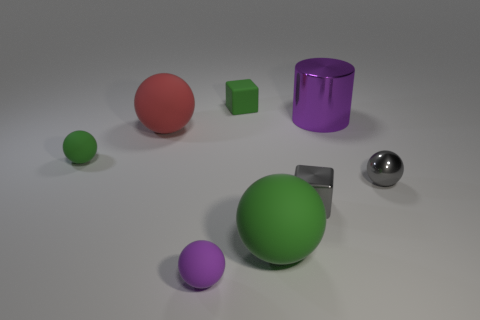What is the size of the green sphere that is right of the small cube behind the red matte object?
Make the answer very short. Large. What number of tiny objects are the same color as the cylinder?
Your answer should be very brief. 1. What shape is the purple thing behind the green thing that is on the left side of the green matte block?
Keep it short and to the point. Cylinder. How many green balls have the same material as the tiny green block?
Provide a succinct answer. 2. There is a small ball that is in front of the gray metal ball; what is its material?
Offer a terse response. Rubber. What shape is the large rubber thing that is behind the small cube in front of the purple object behind the small gray cube?
Provide a succinct answer. Sphere. Is the color of the big matte thing on the right side of the matte cube the same as the large thing that is left of the tiny green matte cube?
Give a very brief answer. No. Is the number of purple objects left of the tiny green rubber block less than the number of things that are right of the tiny purple thing?
Your response must be concise. Yes. Are there any other things that have the same shape as the small purple matte thing?
Offer a very short reply. Yes. The other metal object that is the same shape as the tiny purple thing is what color?
Give a very brief answer. Gray. 